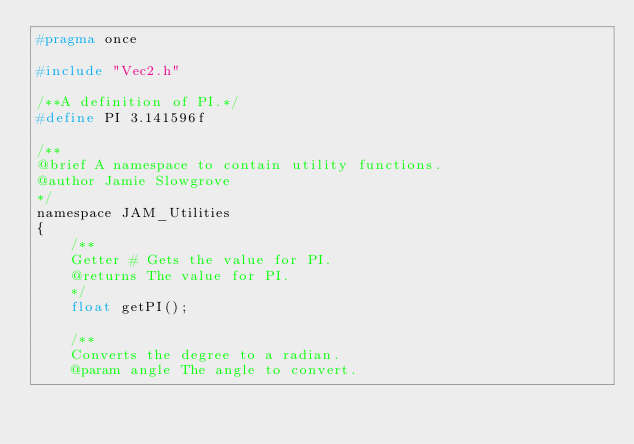Convert code to text. <code><loc_0><loc_0><loc_500><loc_500><_C_>#pragma once

#include "Vec2.h"

/**A definition of PI.*/
#define PI 3.141596f

/**
@brief A namespace to contain utility functions.
@author Jamie Slowgrove
*/
namespace JAM_Utilities
{
	/**
	Getter # Gets the value for PI.
	@returns The value for PI.
	*/
	float getPI();

	/**
	Converts the degree to a radian.
	@param angle The angle to convert.</code> 